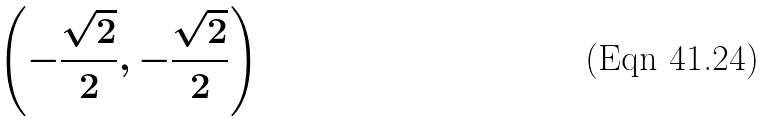Convert formula to latex. <formula><loc_0><loc_0><loc_500><loc_500>\left ( - { \frac { \sqrt { 2 } } { 2 } } , - { \frac { \sqrt { 2 } } { 2 } } \right )</formula> 